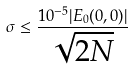<formula> <loc_0><loc_0><loc_500><loc_500>\sigma \leq \frac { 1 0 ^ { - 5 } | E _ { 0 } ( 0 , 0 ) | } { \sqrt { 2 N } }</formula> 